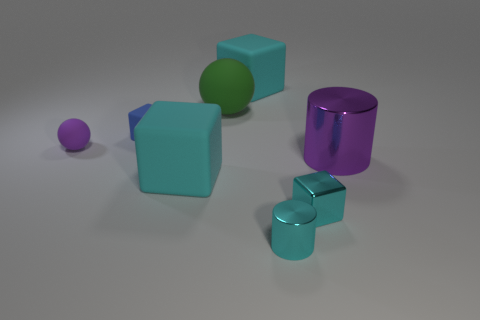Subtract all brown cylinders. How many cyan blocks are left? 3 Subtract 1 blocks. How many blocks are left? 3 Add 1 small cyan metal objects. How many objects exist? 9 Subtract all gray cubes. Subtract all brown spheres. How many cubes are left? 4 Subtract all cylinders. How many objects are left? 6 Add 4 large cyan rubber blocks. How many large cyan rubber blocks exist? 6 Subtract 0 brown cylinders. How many objects are left? 8 Subtract all large purple cylinders. Subtract all large purple metal objects. How many objects are left? 6 Add 8 large purple metallic things. How many large purple metallic things are left? 9 